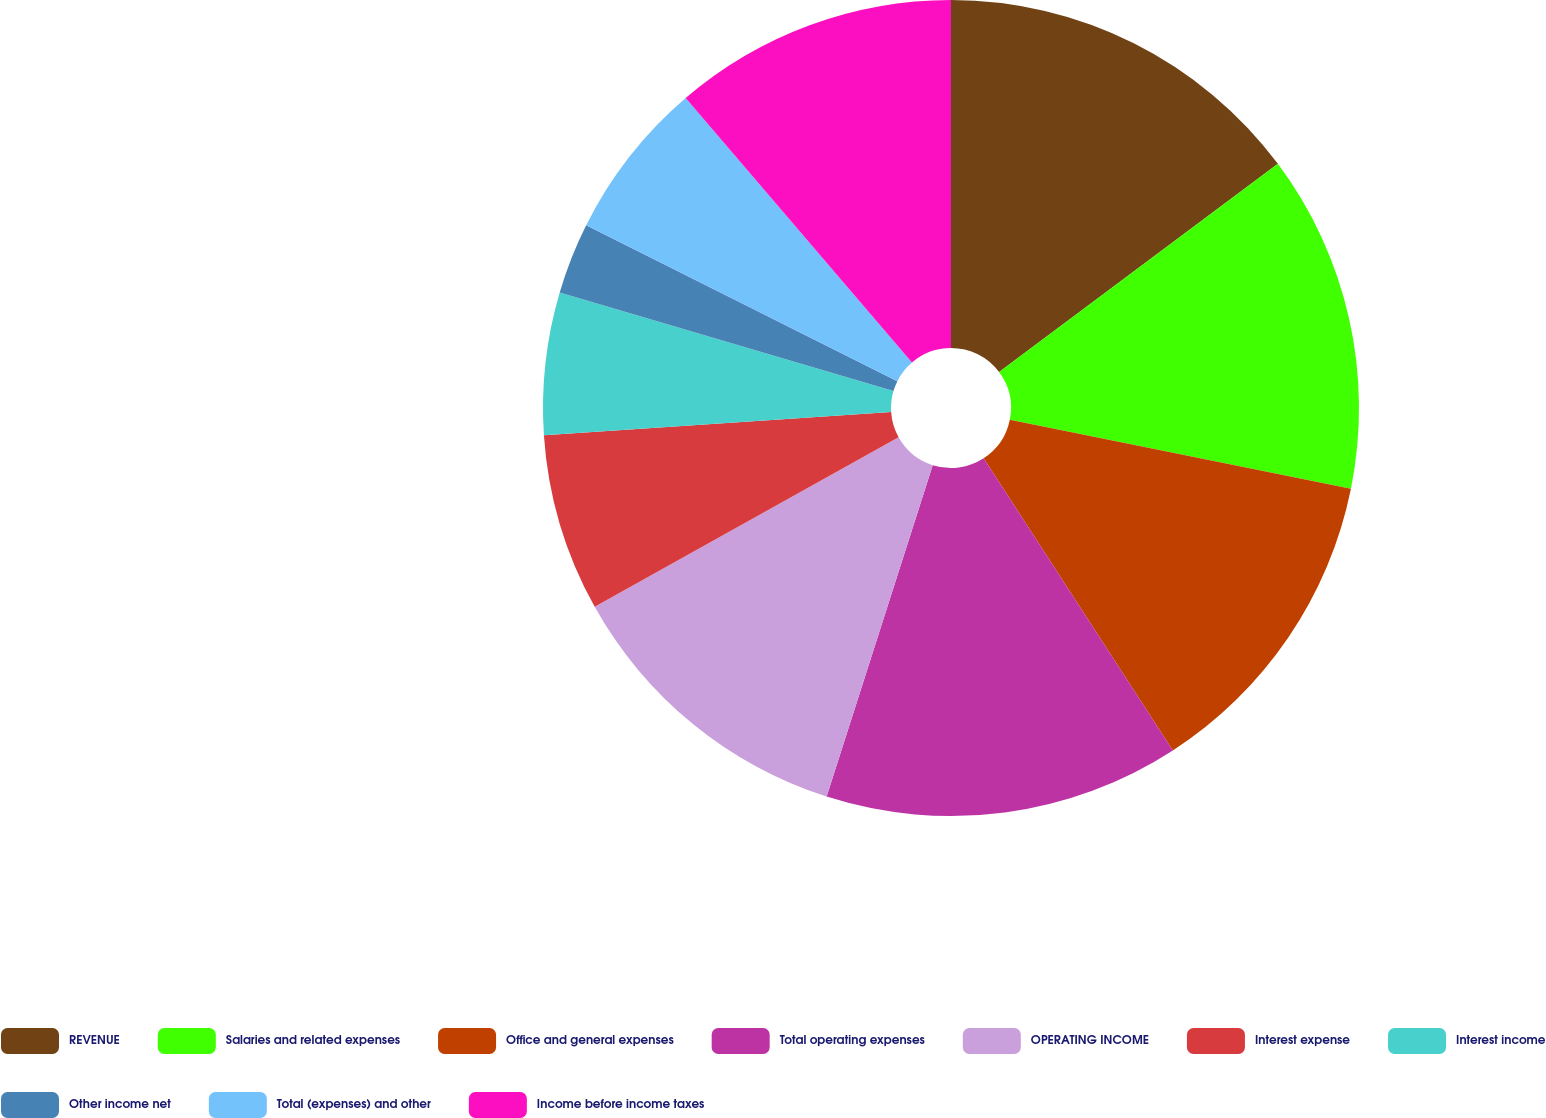<chart> <loc_0><loc_0><loc_500><loc_500><pie_chart><fcel>REVENUE<fcel>Salaries and related expenses<fcel>Office and general expenses<fcel>Total operating expenses<fcel>OPERATING INCOME<fcel>Interest expense<fcel>Interest income<fcel>Other income net<fcel>Total (expenses) and other<fcel>Income before income taxes<nl><fcel>14.79%<fcel>13.38%<fcel>12.68%<fcel>14.08%<fcel>11.97%<fcel>7.04%<fcel>5.63%<fcel>2.82%<fcel>6.34%<fcel>11.27%<nl></chart> 